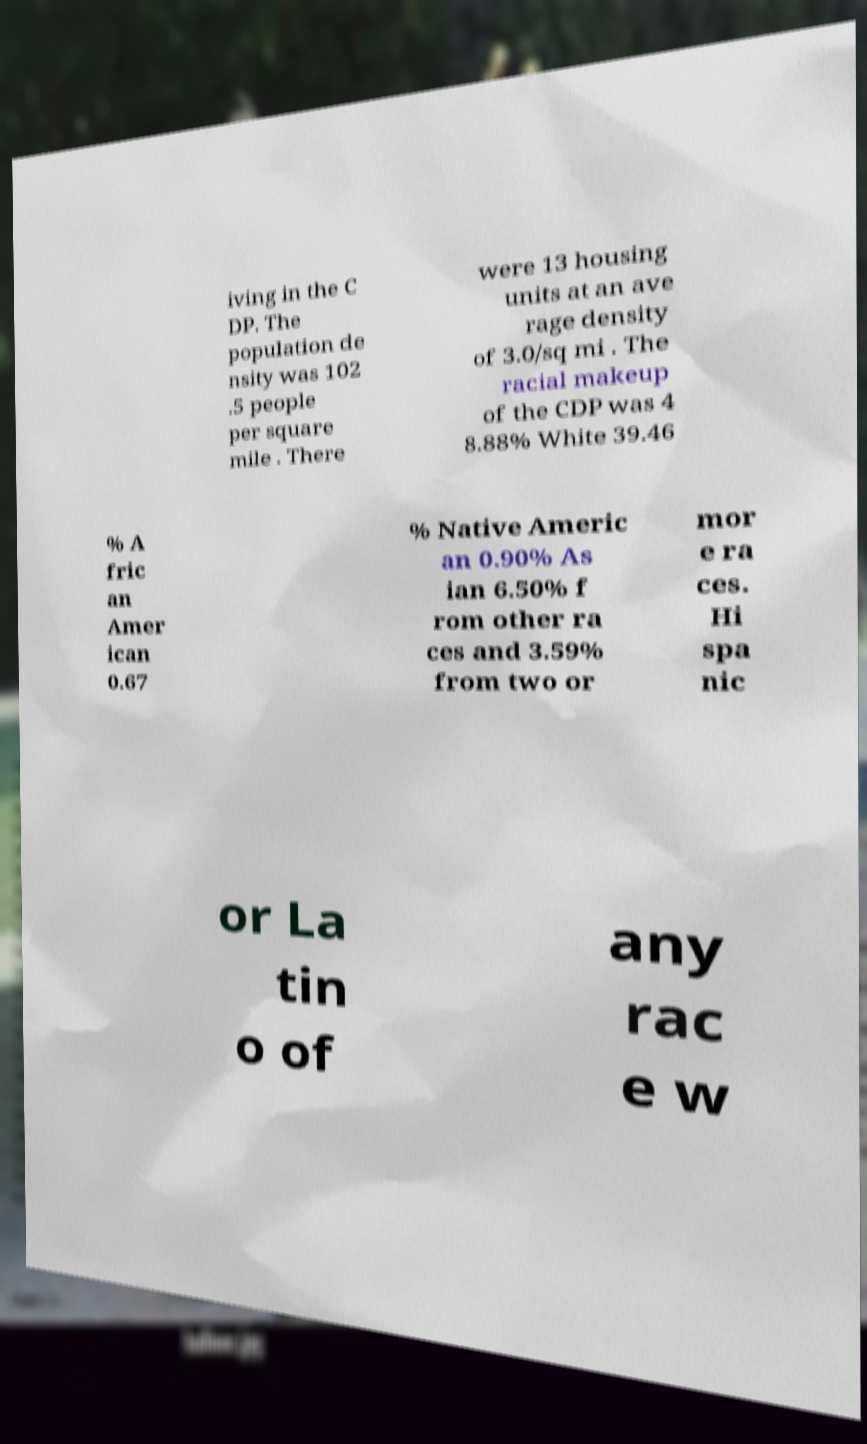For documentation purposes, I need the text within this image transcribed. Could you provide that? iving in the C DP. The population de nsity was 102 .5 people per square mile . There were 13 housing units at an ave rage density of 3.0/sq mi . The racial makeup of the CDP was 4 8.88% White 39.46 % A fric an Amer ican 0.67 % Native Americ an 0.90% As ian 6.50% f rom other ra ces and 3.59% from two or mor e ra ces. Hi spa nic or La tin o of any rac e w 